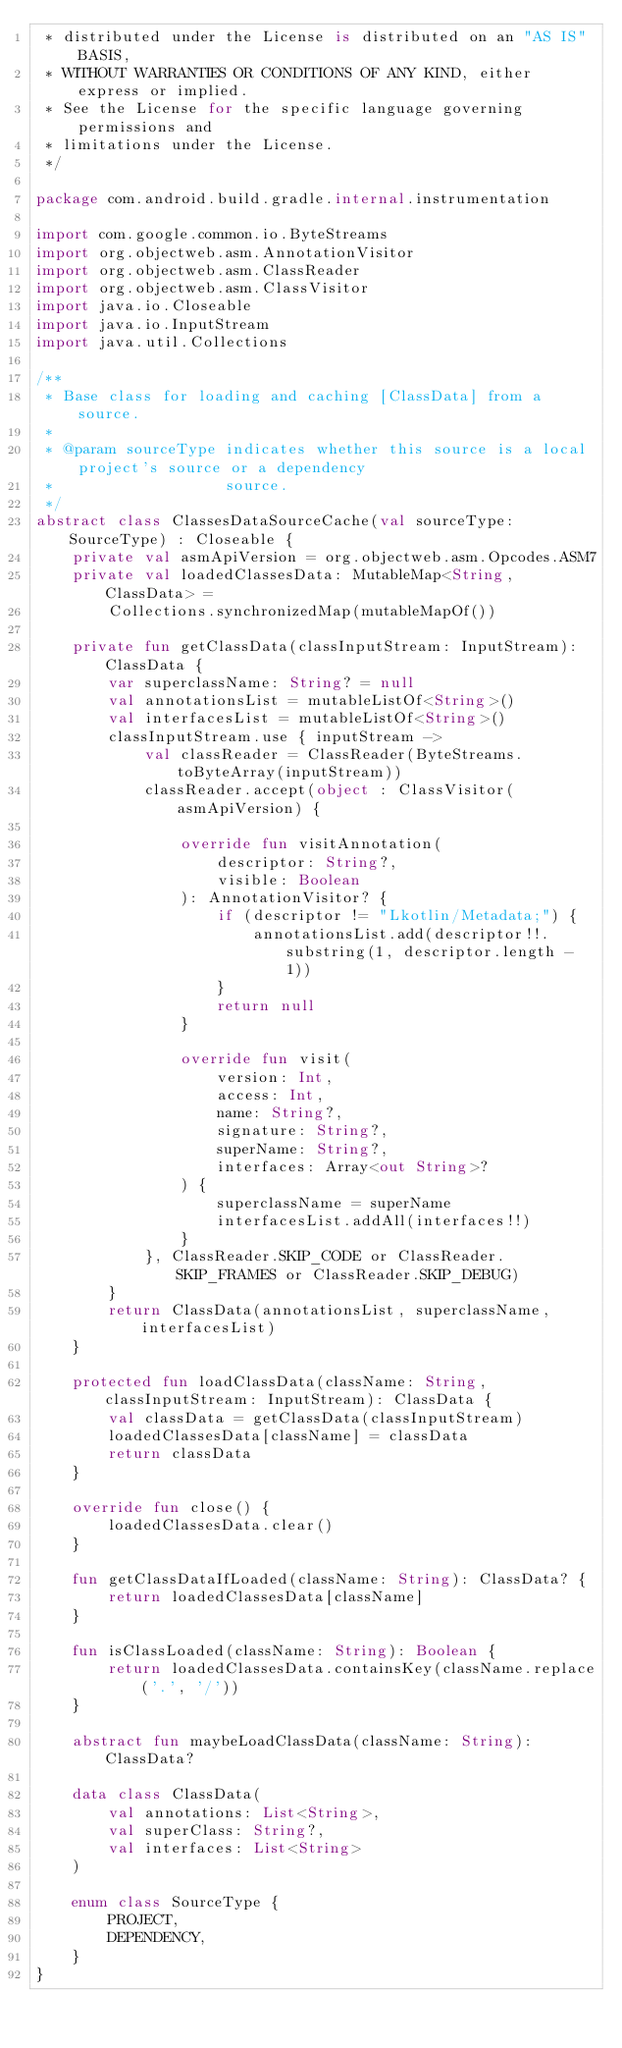<code> <loc_0><loc_0><loc_500><loc_500><_Kotlin_> * distributed under the License is distributed on an "AS IS" BASIS,
 * WITHOUT WARRANTIES OR CONDITIONS OF ANY KIND, either express or implied.
 * See the License for the specific language governing permissions and
 * limitations under the License.
 */

package com.android.build.gradle.internal.instrumentation

import com.google.common.io.ByteStreams
import org.objectweb.asm.AnnotationVisitor
import org.objectweb.asm.ClassReader
import org.objectweb.asm.ClassVisitor
import java.io.Closeable
import java.io.InputStream
import java.util.Collections

/**
 * Base class for loading and caching [ClassData] from a source.
 *
 * @param sourceType indicates whether this source is a local project's source or a dependency
 *                   source.
 */
abstract class ClassesDataSourceCache(val sourceType: SourceType) : Closeable {
    private val asmApiVersion = org.objectweb.asm.Opcodes.ASM7
    private val loadedClassesData: MutableMap<String, ClassData> =
        Collections.synchronizedMap(mutableMapOf())

    private fun getClassData(classInputStream: InputStream): ClassData {
        var superclassName: String? = null
        val annotationsList = mutableListOf<String>()
        val interfacesList = mutableListOf<String>()
        classInputStream.use { inputStream ->
            val classReader = ClassReader(ByteStreams.toByteArray(inputStream))
            classReader.accept(object : ClassVisitor(asmApiVersion) {

                override fun visitAnnotation(
                    descriptor: String?,
                    visible: Boolean
                ): AnnotationVisitor? {
                    if (descriptor != "Lkotlin/Metadata;") {
                        annotationsList.add(descriptor!!.substring(1, descriptor.length - 1))
                    }
                    return null
                }

                override fun visit(
                    version: Int,
                    access: Int,
                    name: String?,
                    signature: String?,
                    superName: String?,
                    interfaces: Array<out String>?
                ) {
                    superclassName = superName
                    interfacesList.addAll(interfaces!!)
                }
            }, ClassReader.SKIP_CODE or ClassReader.SKIP_FRAMES or ClassReader.SKIP_DEBUG)
        }
        return ClassData(annotationsList, superclassName, interfacesList)
    }

    protected fun loadClassData(className: String, classInputStream: InputStream): ClassData {
        val classData = getClassData(classInputStream)
        loadedClassesData[className] = classData
        return classData
    }

    override fun close() {
        loadedClassesData.clear()
    }

    fun getClassDataIfLoaded(className: String): ClassData? {
        return loadedClassesData[className]
    }

    fun isClassLoaded(className: String): Boolean {
        return loadedClassesData.containsKey(className.replace('.', '/'))
    }

    abstract fun maybeLoadClassData(className: String): ClassData?

    data class ClassData(
        val annotations: List<String>,
        val superClass: String?,
        val interfaces: List<String>
    )

    enum class SourceType {
        PROJECT,
        DEPENDENCY,
    }
}
</code> 